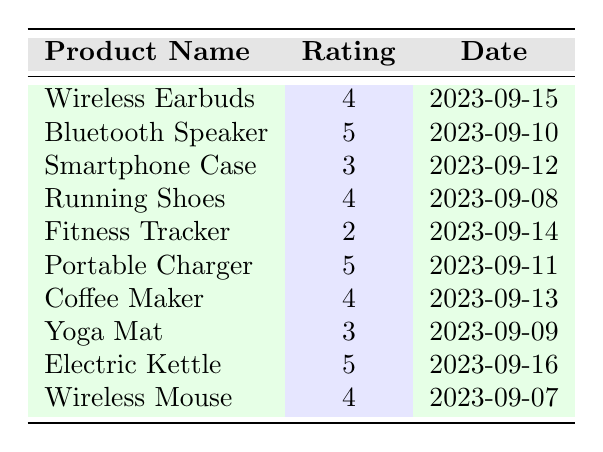What is the highest rating given to a product? The table lists several products with their ratings. The highest rating mentioned is 5, which is for the "Bluetooth Speaker," "Portable Charger," and "Electric Kettle."
Answer: 5 How many products received a rating of 4? The table shows that "Wireless Earbuds," "Running Shoes," "Coffee Maker," and "Wireless Mouse" each have a rating of 4. Counting these, there are 4 products.
Answer: 4 Is there a product that received a rating of 2? Upon reviewing the table, "Fitness Tracker" is the only product that received a rating of 2.
Answer: Yes What is the average rating of all products listed? To find the average, sum the ratings: (4 + 5 + 3 + 4 + 2 + 5 + 4 + 3 + 5 + 4) = 43. There are 10 products, so the average is 43/10 = 4.3.
Answer: 4.3 Which product has the most recent feedback date? The most recent date in the table is "2023-09-16" for the "Electric Kettle."
Answer: Electric Kettle How many products have a rating below 3? Only the "Fitness Tracker," which has a rating of 2, is lower than 3. So, there is just one product.
Answer: 1 What is the total number of ratings that are at least 4? The products rated at least 4 are "Wireless Earbuds," "Bluetooth Speaker," "Running Shoes," "Portable Charger," "Coffee Maker," "Wireless Mouse," and "Electric Kettle." Counting these, there are 6 ratings of at least 4.
Answer: 6 Is the "Smartphone Case" rated higher than the "Yoga Mat"? The "Smartphone Case" has a rating of 3, while the "Yoga Mat" also has a rating of 3. Neither is rated higher than the other, so they are equal.
Answer: No Which product has a rating of 3 and what is the customer's comment on it? Two products receive a rating of 3: "Smartphone Case" with the comment "Decent protection but a bit bulky," and "Yoga Mat," which has the comment "Comfortable but slippery when wet."
Answer: Smartphone Case: "Decent protection but a bit bulky"; Yoga Mat: "Comfortable but slippery when wet" What is the difference between the highest rating and the lowest rating? The highest rating is 5 (products rated this way include "Bluetooth Speaker," "Portable Charger," and "Electric Kettle") and the lowest is 2 ("Fitness Tracker"). Thus the difference is 5 - 2 = 3.
Answer: 3 